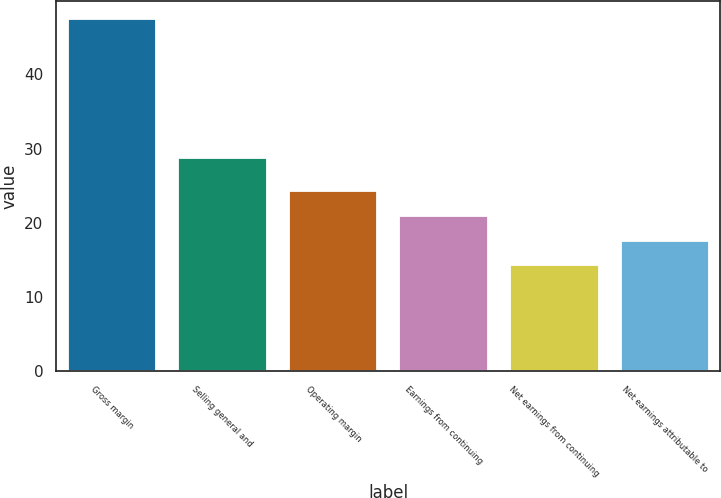<chart> <loc_0><loc_0><loc_500><loc_500><bar_chart><fcel>Gross margin<fcel>Selling general and<fcel>Operating margin<fcel>Earnings from continuing<fcel>Net earnings from continuing<fcel>Net earnings attributable to<nl><fcel>47.5<fcel>28.8<fcel>24.26<fcel>20.94<fcel>14.3<fcel>17.62<nl></chart> 